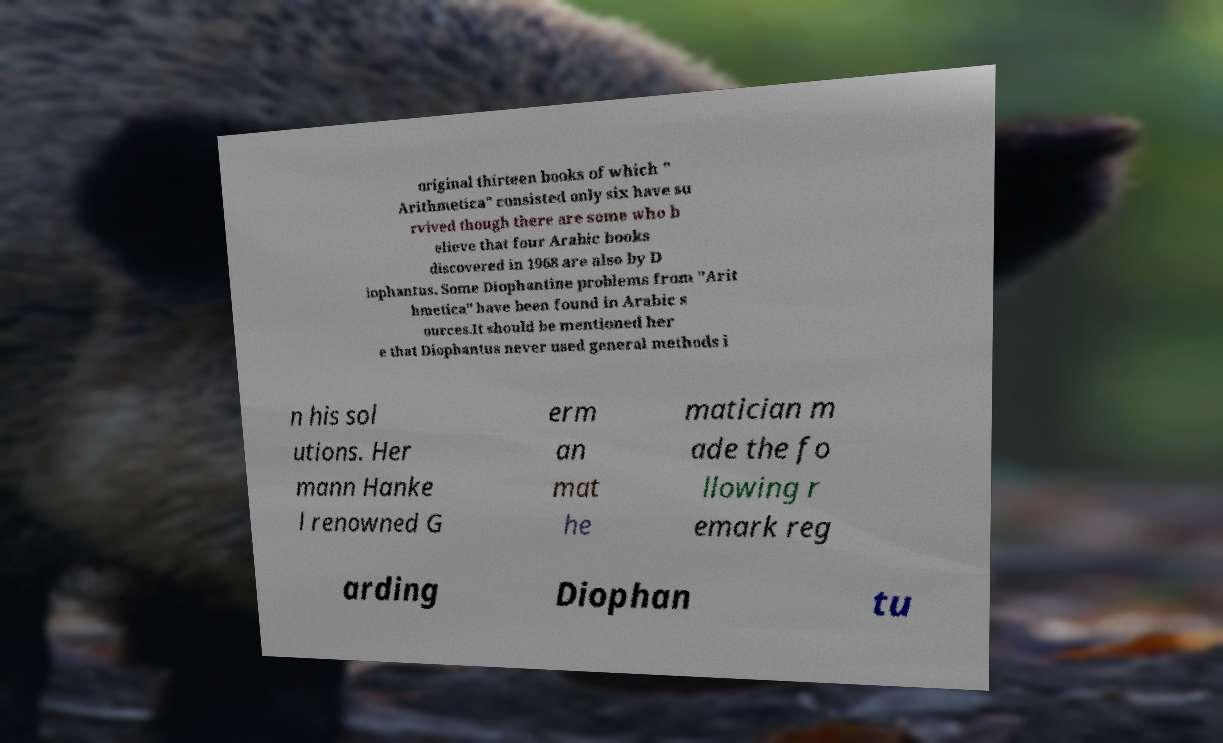Please identify and transcribe the text found in this image. original thirteen books of which " Arithmetica" consisted only six have su rvived though there are some who b elieve that four Arabic books discovered in 1968 are also by D iophantus. Some Diophantine problems from "Arit hmetica" have been found in Arabic s ources.It should be mentioned her e that Diophantus never used general methods i n his sol utions. Her mann Hanke l renowned G erm an mat he matician m ade the fo llowing r emark reg arding Diophan tu 